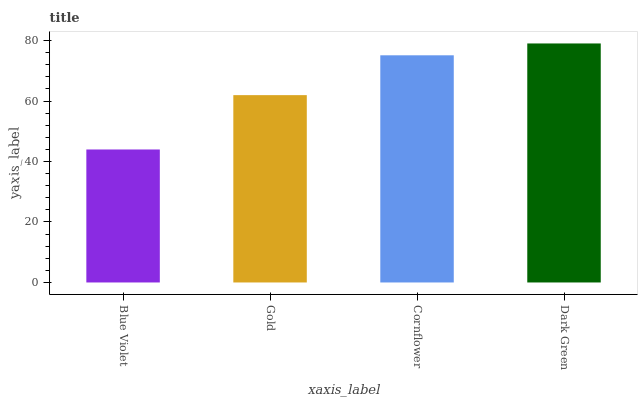Is Gold the minimum?
Answer yes or no. No. Is Gold the maximum?
Answer yes or no. No. Is Gold greater than Blue Violet?
Answer yes or no. Yes. Is Blue Violet less than Gold?
Answer yes or no. Yes. Is Blue Violet greater than Gold?
Answer yes or no. No. Is Gold less than Blue Violet?
Answer yes or no. No. Is Cornflower the high median?
Answer yes or no. Yes. Is Gold the low median?
Answer yes or no. Yes. Is Blue Violet the high median?
Answer yes or no. No. Is Cornflower the low median?
Answer yes or no. No. 